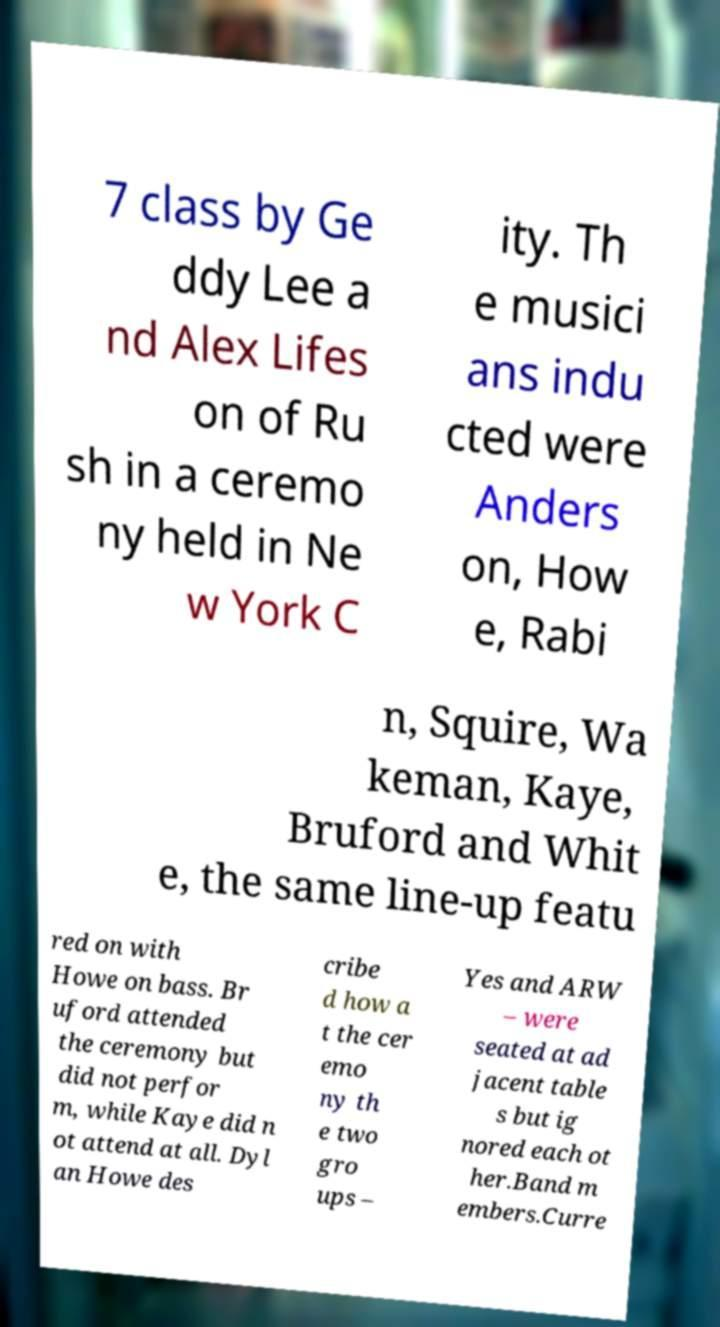Please read and relay the text visible in this image. What does it say? 7 class by Ge ddy Lee a nd Alex Lifes on of Ru sh in a ceremo ny held in Ne w York C ity. Th e musici ans indu cted were Anders on, How e, Rabi n, Squire, Wa keman, Kaye, Bruford and Whit e, the same line-up featu red on with Howe on bass. Br uford attended the ceremony but did not perfor m, while Kaye did n ot attend at all. Dyl an Howe des cribe d how a t the cer emo ny th e two gro ups – Yes and ARW – were seated at ad jacent table s but ig nored each ot her.Band m embers.Curre 